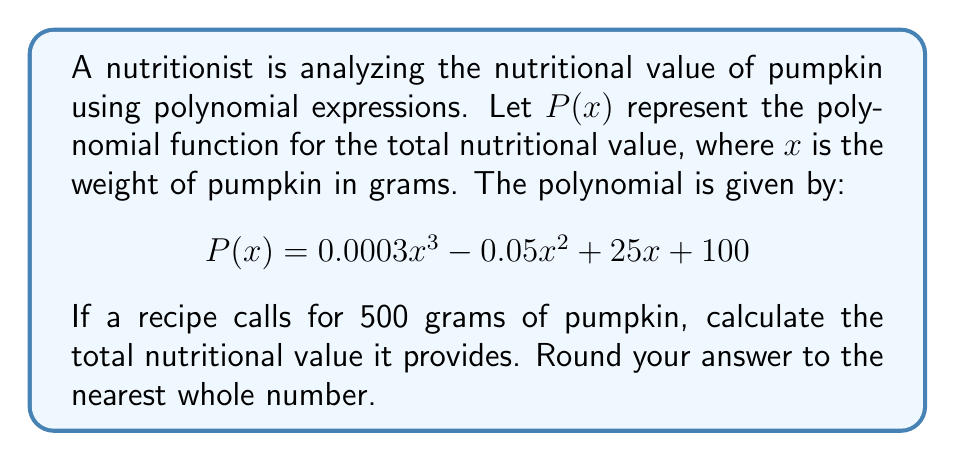Help me with this question. To solve this problem, we need to evaluate the polynomial $P(x)$ at $x = 500$. Let's do this step by step:

1) We have $P(x) = 0.0003x^3 - 0.05x^2 + 25x + 100$, and we need to find $P(500)$.

2) Let's substitute $x = 500$ into the polynomial:

   $P(500) = 0.0003(500)^3 - 0.05(500)^2 + 25(500) + 100$

3) Now, let's evaluate each term:

   a) $0.0003(500)^3 = 0.0003 \times 125,000,000 = 37,500$
   b) $-0.05(500)^2 = -0.05 \times 250,000 = -12,500$
   c) $25(500) = 12,500$
   d) $100$ remains as is

4) Adding all these terms:

   $P(500) = 37,500 - 12,500 + 12,500 + 100 = 37,600$

5) The question asks to round to the nearest whole number, but our result is already a whole number.

Therefore, the total nutritional value provided by 500 grams of pumpkin is 37,600 units.
Answer: 37,600 